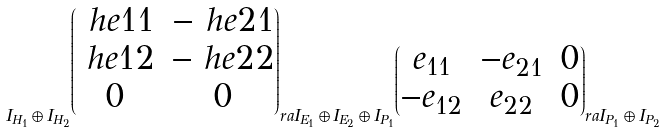Convert formula to latex. <formula><loc_0><loc_0><loc_500><loc_500>I _ { H _ { 1 } } \oplus I _ { H _ { 2 } } \overset { \begin{pmatrix} \ h e { 1 1 } & - \ h e { 2 1 } \\ \ h e { 1 2 } & - \ h e { 2 2 } \\ 0 & 0 \end{pmatrix} } \ r a I _ { E _ { 1 } } \oplus I _ { E _ { 2 } } \oplus I _ { P _ { 1 } } \overset { \begin{pmatrix} e _ { 1 1 } & - e _ { 2 1 } & 0 \\ - e _ { 1 2 } & e _ { 2 2 } & 0 \end{pmatrix} } \ r a I _ { P _ { 1 } } \oplus I _ { P _ { 2 } }</formula> 